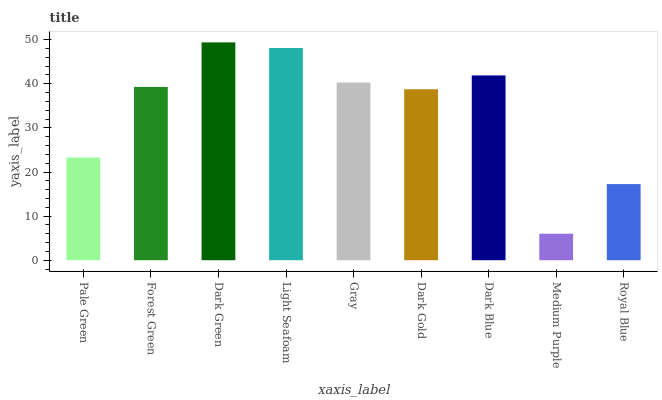Is Medium Purple the minimum?
Answer yes or no. Yes. Is Dark Green the maximum?
Answer yes or no. Yes. Is Forest Green the minimum?
Answer yes or no. No. Is Forest Green the maximum?
Answer yes or no. No. Is Forest Green greater than Pale Green?
Answer yes or no. Yes. Is Pale Green less than Forest Green?
Answer yes or no. Yes. Is Pale Green greater than Forest Green?
Answer yes or no. No. Is Forest Green less than Pale Green?
Answer yes or no. No. Is Forest Green the high median?
Answer yes or no. Yes. Is Forest Green the low median?
Answer yes or no. Yes. Is Light Seafoam the high median?
Answer yes or no. No. Is Pale Green the low median?
Answer yes or no. No. 